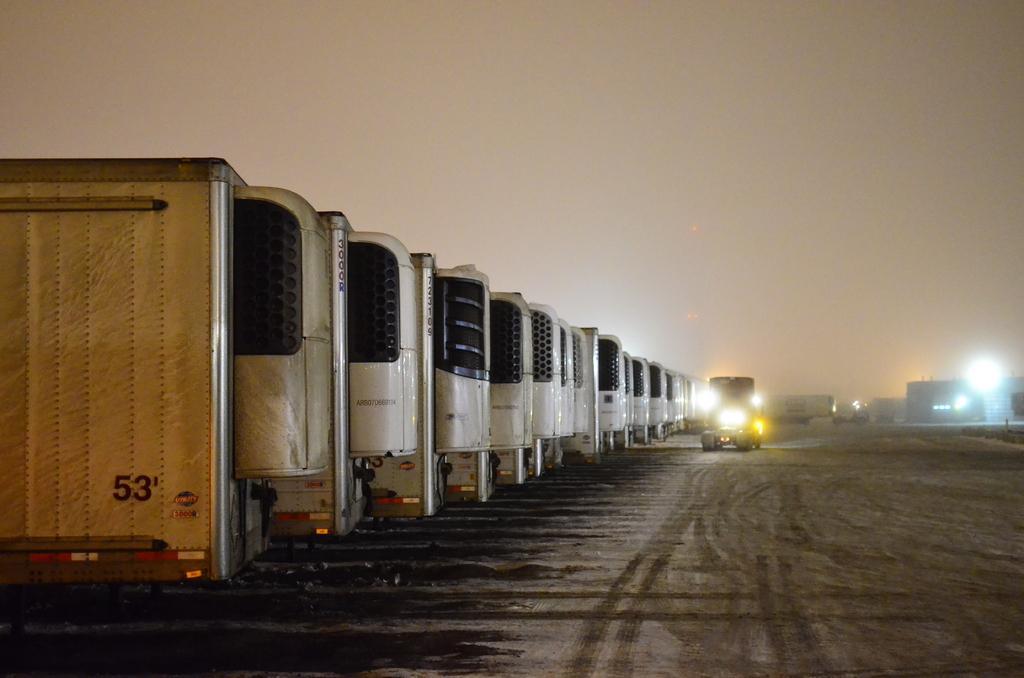How would you summarize this image in a sentence or two? In this image there are trucks. In the background of the image there are buildings, lights. At the top of the image there is sky. At the bottom of the image there is sand. 